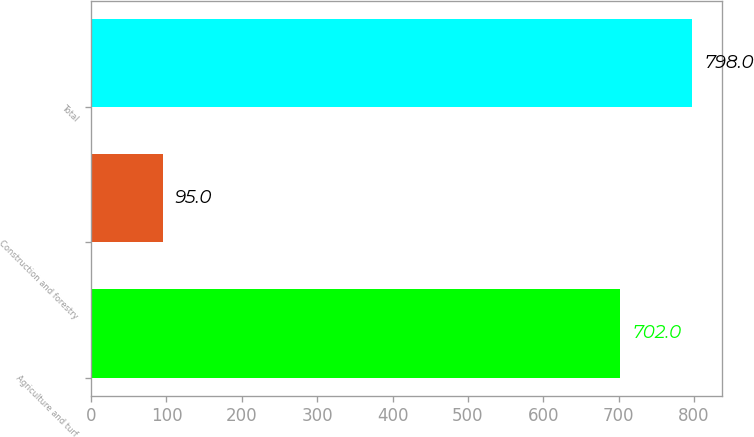Convert chart. <chart><loc_0><loc_0><loc_500><loc_500><bar_chart><fcel>Agriculture and turf<fcel>Construction and forestry<fcel>Total<nl><fcel>702<fcel>95<fcel>798<nl></chart> 